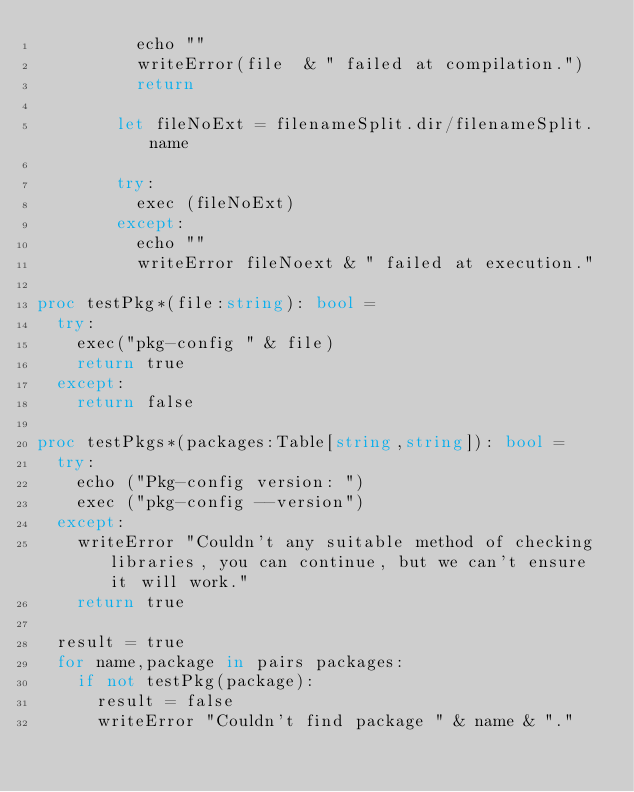<code> <loc_0><loc_0><loc_500><loc_500><_Nim_>          echo ""
          writeError(file  & " failed at compilation.")
          return

        let fileNoExt = filenameSplit.dir/filenameSplit.name

        try:
          exec (fileNoExt)
        except:
          echo ""
          writeError fileNoext & " failed at execution."

proc testPkg*(file:string): bool =
  try:
    exec("pkg-config " & file)
    return true
  except:
    return false

proc testPkgs*(packages:Table[string,string]): bool =
  try:
    echo ("Pkg-config version: ")
    exec ("pkg-config --version")
  except:
    writeError "Couldn't any suitable method of checking libraries, you can continue, but we can't ensure it will work."
    return true

  result = true
  for name,package in pairs packages:
    if not testPkg(package):
      result = false
      writeError "Couldn't find package " & name & "."
</code> 